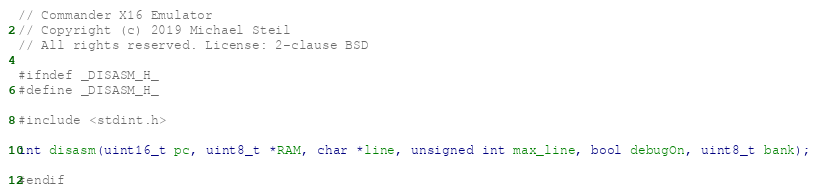Convert code to text. <code><loc_0><loc_0><loc_500><loc_500><_C_>// Commander X16 Emulator
// Copyright (c) 2019 Michael Steil
// All rights reserved. License: 2-clause BSD

#ifndef _DISASM_H_
#define _DISASM_H_

#include <stdint.h>

int disasm(uint16_t pc, uint8_t *RAM, char *line, unsigned int max_line, bool debugOn, uint8_t bank);

#endif
</code> 